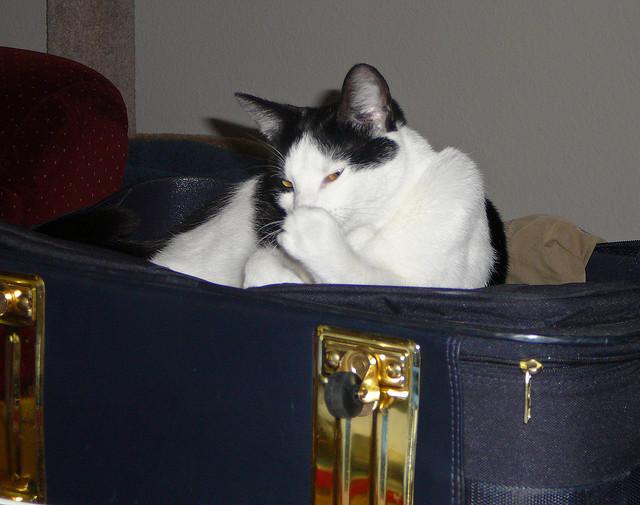What is the cat sitting on?
Answer briefly. Suitcase. Is the cat cleaning itself?
Give a very brief answer. Yes. Is the cat sleeping?
Concise answer only. No. 